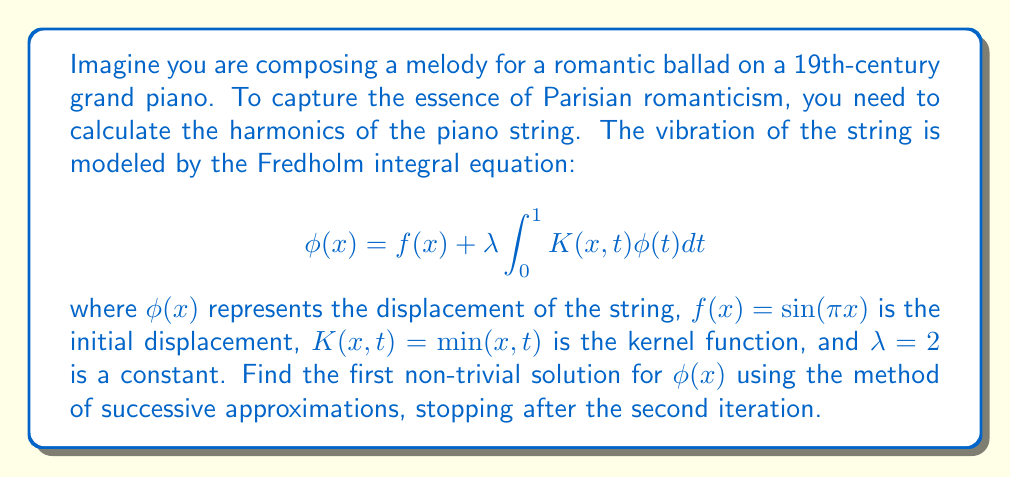Show me your answer to this math problem. To solve this problem, we'll use the method of successive approximations:

1) Start with $\phi_0(x) = f(x) = \sin(\pi x)$

2) For the first iteration:
   $$\phi_1(x) = f(x) + \lambda \int_0^1 K(x,t)\phi_0(t)dt$$
   $$= \sin(\pi x) + 2 \int_0^1 \min(x,t)\sin(\pi t)dt$$

3) To evaluate this integral, we split it into two parts:
   $$= \sin(\pi x) + 2 \left[\int_0^x t\sin(\pi t)dt + \int_x^1 x\sin(\pi t)dt\right]$$

4) Solving these integrals:
   $$= \sin(\pi x) + 2 \left[\frac{t\sin(\pi t)}{\pi} + \frac{\cos(\pi t)}{\pi^2}\right]_0^x - 2x\left[\frac{\cos(\pi t)}{\pi}\right]_x^1$$
   $$= \sin(\pi x) + \frac{2}{\pi}[x\sin(\pi x) + \frac{1}{\pi}(\cos(\pi x) - 1)] + \frac{2x}{\pi}[1 + \cos(\pi x)]$$

5) For the second iteration:
   $$\phi_2(x) = f(x) + \lambda \int_0^1 K(x,t)\phi_1(t)dt$$

6) This leads to a more complex integral, which we can solve similarly:
   $$\phi_2(x) = \sin(\pi x) + \frac{2}{\pi}[x\sin(\pi x) + \frac{1}{\pi}(\cos(\pi x) - 1)] + \frac{2x}{\pi}[1 + \cos(\pi x)]$$
   $$+ \frac{4}{\pi^2}[x^2\sin(\pi x) + \frac{2x}{\pi}(\cos(\pi x) - 1)] + \frac{4x}{\pi^2}[\frac{\pi}{2} - \frac{1}{\pi}(\sin(\pi x) - \pi x)]$$

This is our final approximation for $\phi(x)$ after two iterations.
Answer: $$\phi_2(x) = \sin(\pi x) + \frac{2}{\pi}[x\sin(\pi x) + \frac{1}{\pi}(\cos(\pi x) - 1)] + \frac{2x}{\pi}[1 + \cos(\pi x)] + \frac{4}{\pi^2}[x^2\sin(\pi x) + \frac{2x}{\pi}(\cos(\pi x) - 1)] + \frac{4x}{\pi^2}[\frac{\pi}{2} - \frac{1}{\pi}(\sin(\pi x) - \pi x)]$$ 